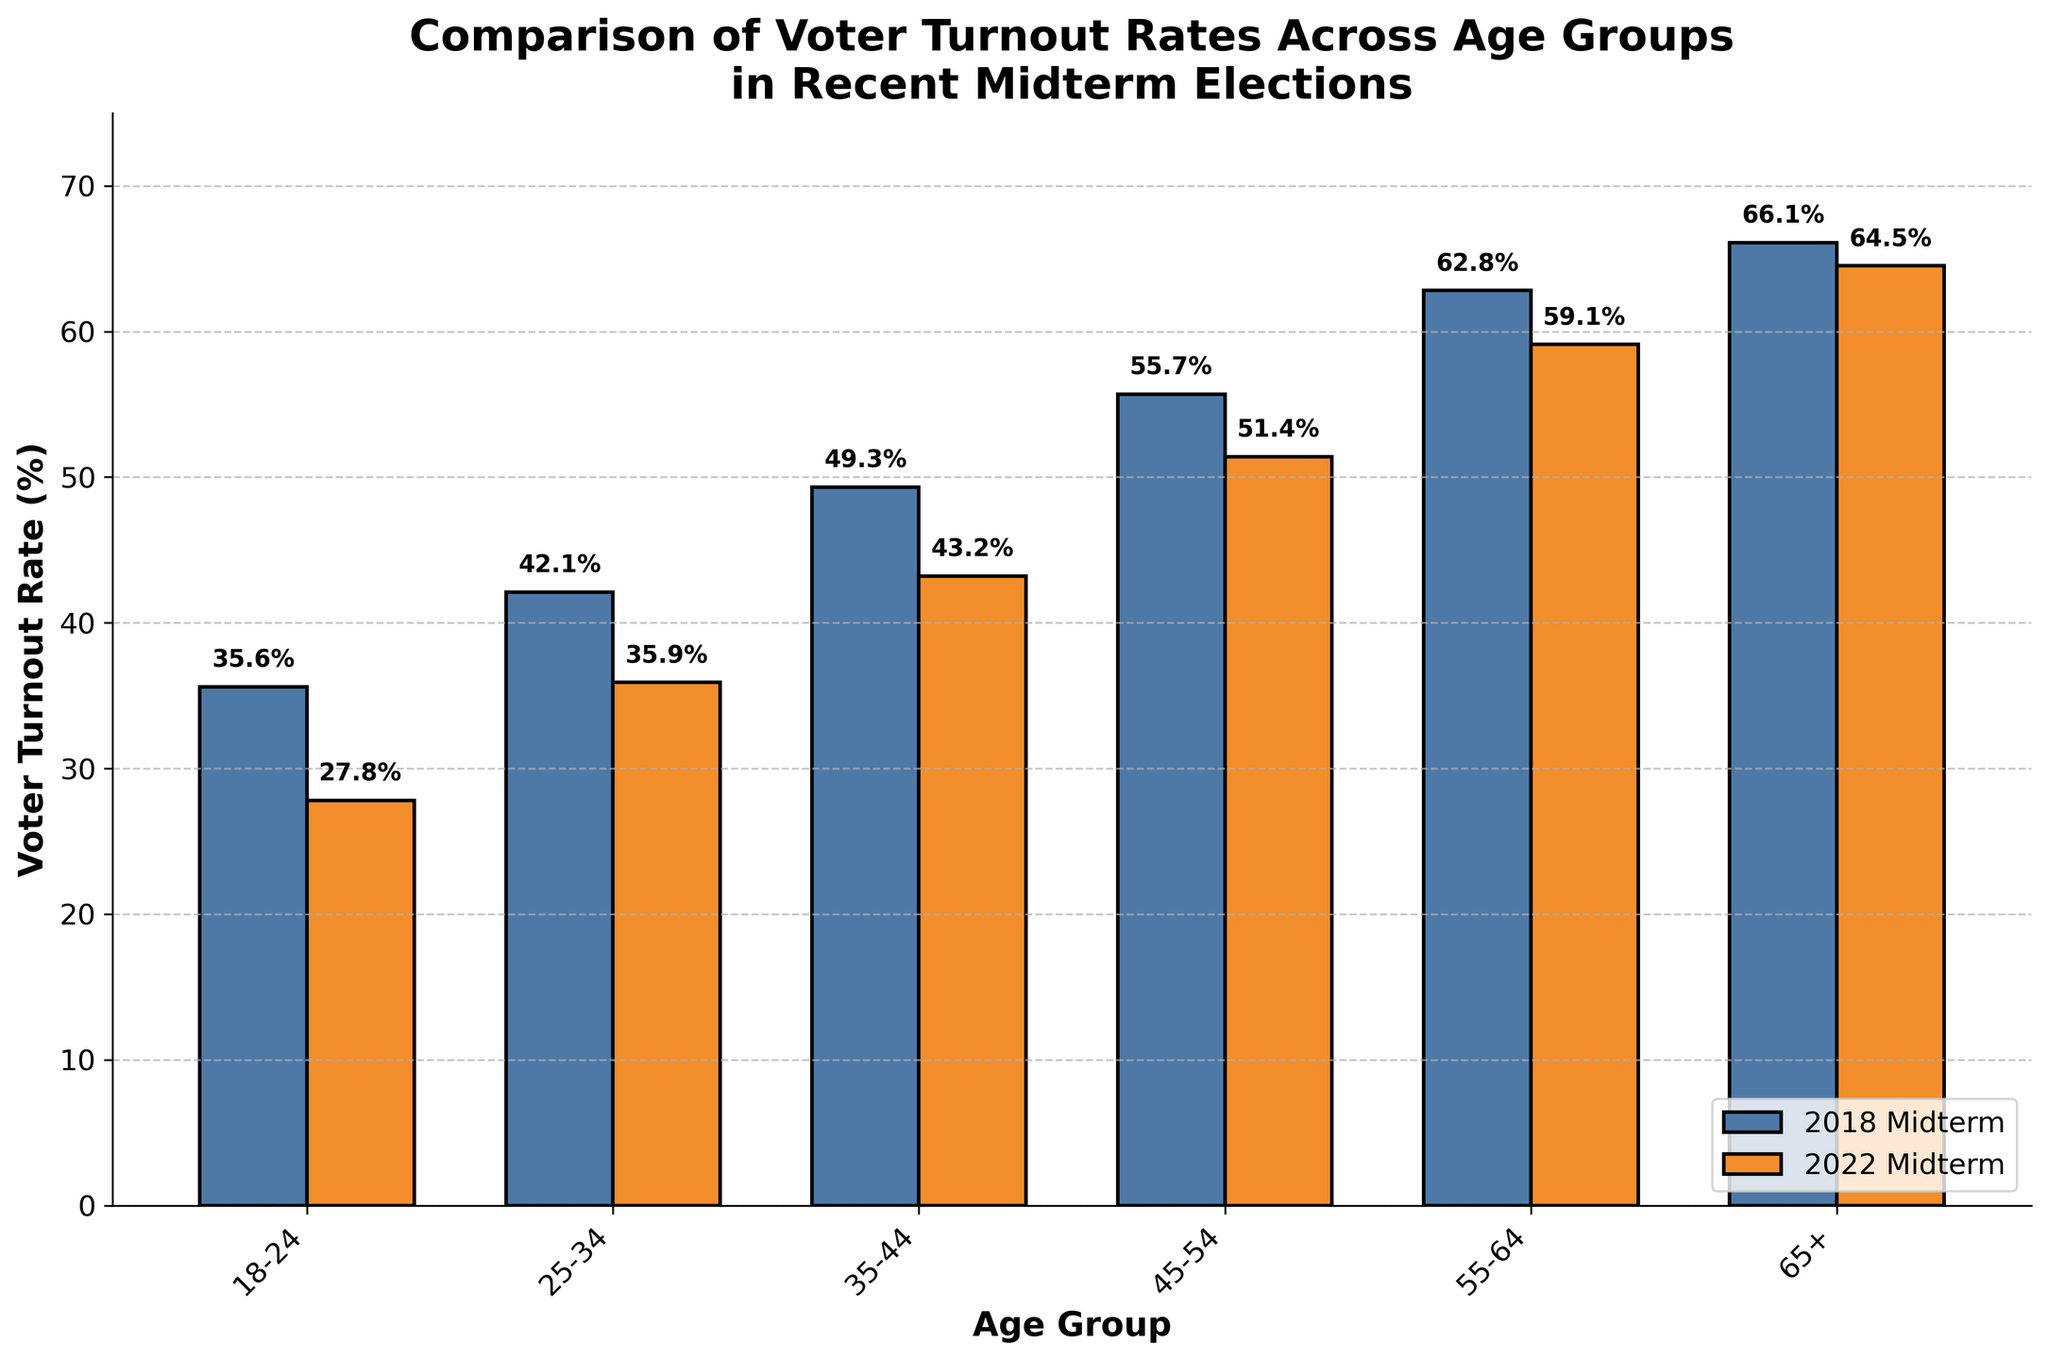What is the voter turnout rate for the 18-24 age group in the 2018 midterm election? Look at the height of the bar for the 18-24 age group in the 2018 midterm election and read the value.
Answer: 35.6% What is the difference in voter turnout rates between the 55-64 and 65+ age groups in the 2022 midterm election? Subtract the voter turnout rate for the 65+ age group (64.5%) from the 55-64 age group (59.1%) in the 2022 midterm election.
Answer: -5.4% Which age group experienced the largest decline in voter turnout rate from the 2018 to the 2022 midterm elections? Calculate the differences in voter turnout rates for each age group between the 2018 and 2022 midterm elections and identify the largest decline.
Answer: 18-24 What is the average voter turnout rate across all age groups in the 2018 midterm election? Add the voter turnout rates for all age groups in the 2018 midterm election, then divide by the number of age groups (6).
Answer: (35.6 + 42.1 + 49.3 + 55.7 + 62.8 + 66.1) / 6 = 51.1% Did any age group see an increase in voter turnout between the 2018 and 2022 midterm elections? Compare the voter turnout rates for each age group between the 2018 and 2022 midterm elections to see if there is an increase for any group.
Answer: No Which midterm election year had a higher voter turnout rate for the 35-44 age group? Compare the voter turnout rates for the 35-44 age group in the 2018 and 2022 midterm elections.
Answer: 2018 What is the total voter turnout rate for the age groups 25-34 and 35-44 in the 2022 midterm election? Add the voter turnout rates for the 25-34 and 35-44 age groups in the 2022 midterm election.
Answer: 35.9 + 43.2 = 79.1% How do the voter turnout rates of the 45-54 and 55-64 age groups compare in the 2018 midterm election? Compare the heights of the bars corresponding to the 45-54 and 55-64 age groups in the 2018 midterm election.
Answer: 55-64 > 45-54 What is the median voter turnout rate for all age groups in the 2022 midterm election? List all voter turnout rates for all age groups in the 2022 midterm election, sort them, and find the middle value or average of the two middle values.
Answer: (35.9 + 43.2 + 51.4) / 3 = 43.5% Which age group had the highest voter turnout rate in the 2018 midterm election? Identify the tallest bar in the 2018 midterm election set of bars.
Answer: 65+ 